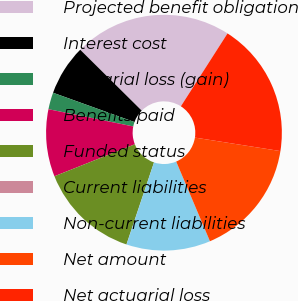<chart> <loc_0><loc_0><loc_500><loc_500><pie_chart><fcel>Projected benefit obligation<fcel>Interest cost<fcel>Actuarial loss (gain)<fcel>Benefits paid<fcel>Funded status<fcel>Current liabilities<fcel>Non-current liabilities<fcel>Net amount<fcel>Net actuarial loss<nl><fcel>21.64%<fcel>6.92%<fcel>2.31%<fcel>9.22%<fcel>13.82%<fcel>0.01%<fcel>11.52%<fcel>16.13%<fcel>18.43%<nl></chart> 